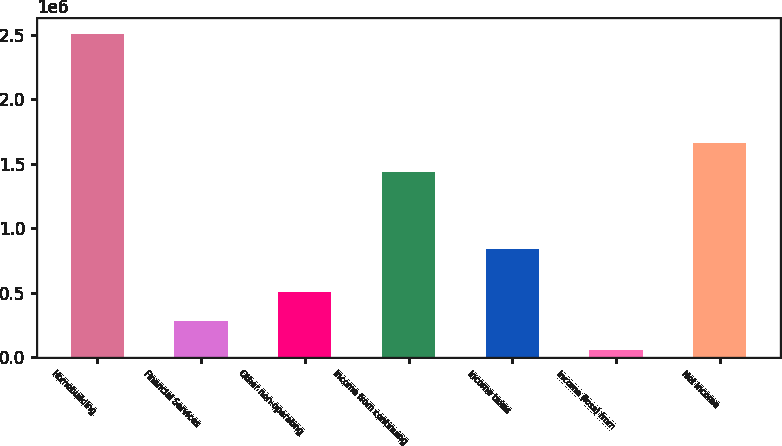Convert chart to OTSL. <chart><loc_0><loc_0><loc_500><loc_500><bar_chart><fcel>Homebuilding<fcel>Financial Services<fcel>Other non-operating<fcel>Income from continuing<fcel>Income taxes<fcel>Income (loss) from<fcel>Net income<nl><fcel>2.50139e+06<fcel>279405<fcel>503784<fcel>1.43689e+06<fcel>840126<fcel>55025<fcel>1.66127e+06<nl></chart> 